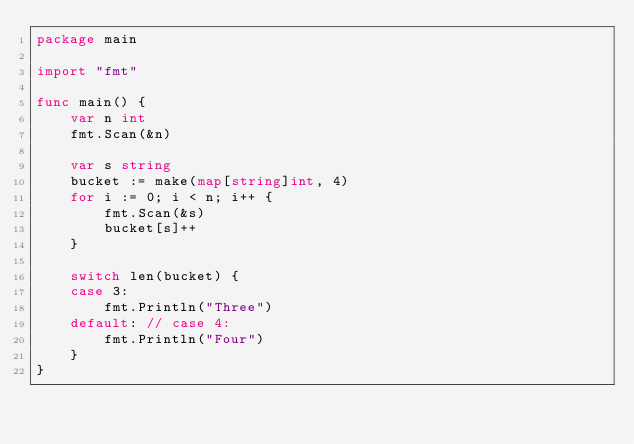<code> <loc_0><loc_0><loc_500><loc_500><_Go_>package main

import "fmt"

func main() {
	var n int
	fmt.Scan(&n)

	var s string
	bucket := make(map[string]int, 4)
	for i := 0; i < n; i++ {
		fmt.Scan(&s)
		bucket[s]++
	}

	switch len(bucket) {
	case 3:
		fmt.Println("Three")
	default: // case 4:
		fmt.Println("Four")
	}
}
</code> 